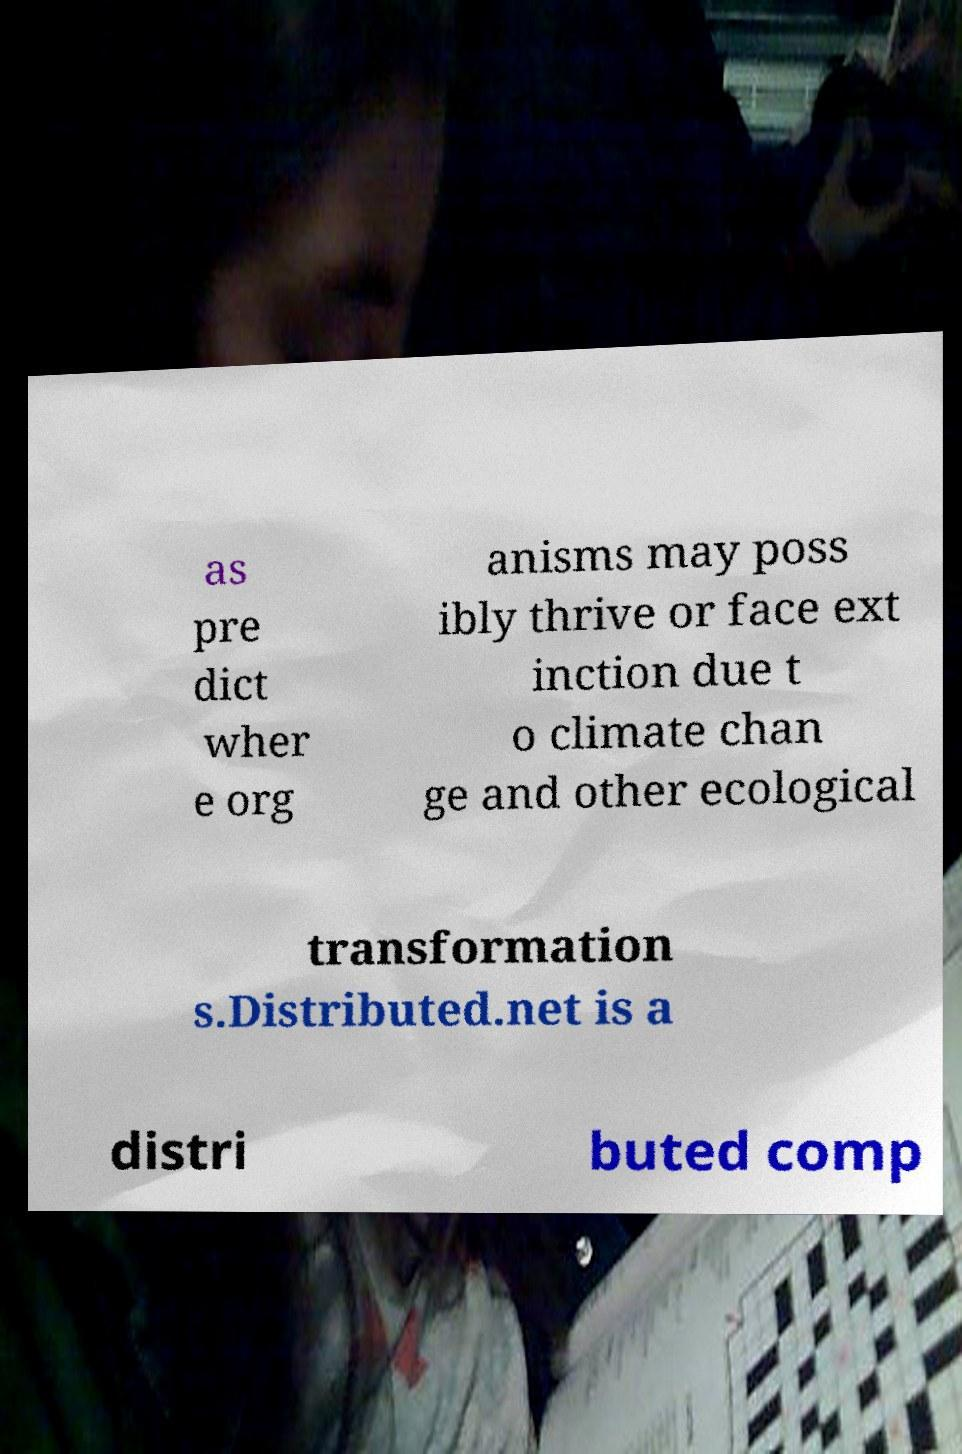Could you assist in decoding the text presented in this image and type it out clearly? as pre dict wher e org anisms may poss ibly thrive or face ext inction due t o climate chan ge and other ecological transformation s.Distributed.net is a distri buted comp 